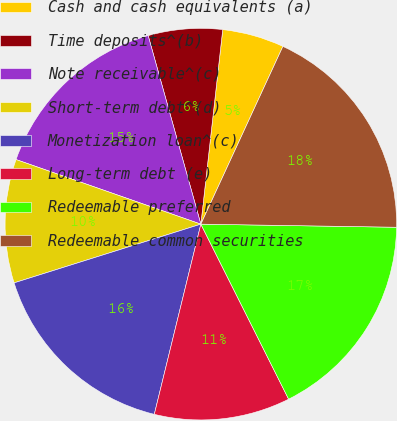<chart> <loc_0><loc_0><loc_500><loc_500><pie_chart><fcel>Cash and cash equivalents (a)<fcel>Time deposits^(b)<fcel>Note receivable^(c)<fcel>Short-term debt^(d)<fcel>Monetization loan^(c)<fcel>Long-term debt (e)<fcel>Redeemable preferred<fcel>Redeemable common securities<nl><fcel>5.1%<fcel>6.12%<fcel>15.31%<fcel>10.2%<fcel>16.33%<fcel>11.22%<fcel>17.35%<fcel>18.37%<nl></chart> 